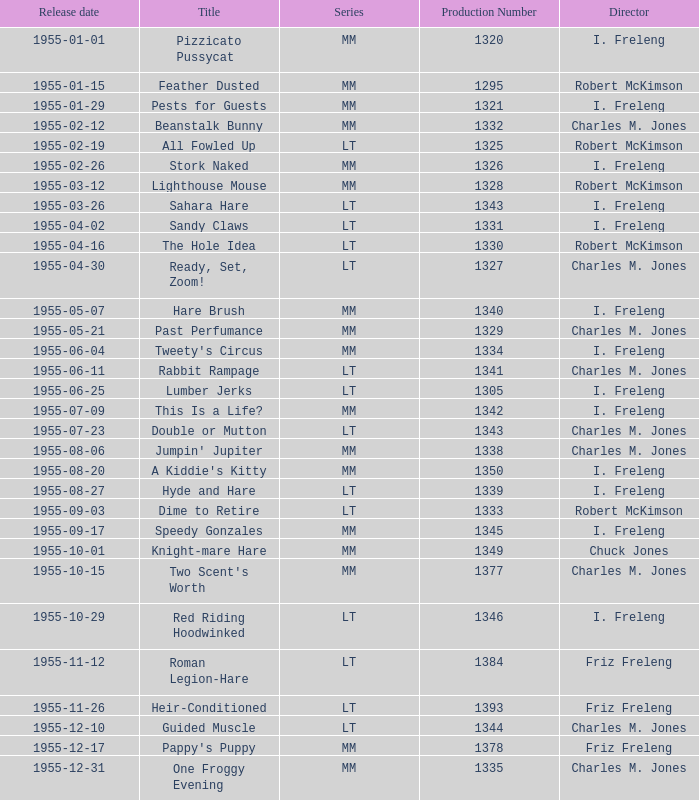Would you mind parsing the complete table? {'header': ['Release date', 'Title', 'Series', 'Production Number', 'Director'], 'rows': [['1955-01-01', 'Pizzicato Pussycat', 'MM', '1320', 'I. Freleng'], ['1955-01-15', 'Feather Dusted', 'MM', '1295', 'Robert McKimson'], ['1955-01-29', 'Pests for Guests', 'MM', '1321', 'I. Freleng'], ['1955-02-12', 'Beanstalk Bunny', 'MM', '1332', 'Charles M. Jones'], ['1955-02-19', 'All Fowled Up', 'LT', '1325', 'Robert McKimson'], ['1955-02-26', 'Stork Naked', 'MM', '1326', 'I. Freleng'], ['1955-03-12', 'Lighthouse Mouse', 'MM', '1328', 'Robert McKimson'], ['1955-03-26', 'Sahara Hare', 'LT', '1343', 'I. Freleng'], ['1955-04-02', 'Sandy Claws', 'LT', '1331', 'I. Freleng'], ['1955-04-16', 'The Hole Idea', 'LT', '1330', 'Robert McKimson'], ['1955-04-30', 'Ready, Set, Zoom!', 'LT', '1327', 'Charles M. Jones'], ['1955-05-07', 'Hare Brush', 'MM', '1340', 'I. Freleng'], ['1955-05-21', 'Past Perfumance', 'MM', '1329', 'Charles M. Jones'], ['1955-06-04', "Tweety's Circus", 'MM', '1334', 'I. Freleng'], ['1955-06-11', 'Rabbit Rampage', 'LT', '1341', 'Charles M. Jones'], ['1955-06-25', 'Lumber Jerks', 'LT', '1305', 'I. Freleng'], ['1955-07-09', 'This Is a Life?', 'MM', '1342', 'I. Freleng'], ['1955-07-23', 'Double or Mutton', 'LT', '1343', 'Charles M. Jones'], ['1955-08-06', "Jumpin' Jupiter", 'MM', '1338', 'Charles M. Jones'], ['1955-08-20', "A Kiddie's Kitty", 'MM', '1350', 'I. Freleng'], ['1955-08-27', 'Hyde and Hare', 'LT', '1339', 'I. Freleng'], ['1955-09-03', 'Dime to Retire', 'LT', '1333', 'Robert McKimson'], ['1955-09-17', 'Speedy Gonzales', 'MM', '1345', 'I. Freleng'], ['1955-10-01', 'Knight-mare Hare', 'MM', '1349', 'Chuck Jones'], ['1955-10-15', "Two Scent's Worth", 'MM', '1377', 'Charles M. Jones'], ['1955-10-29', 'Red Riding Hoodwinked', 'LT', '1346', 'I. Freleng'], ['1955-11-12', 'Roman Legion-Hare', 'LT', '1384', 'Friz Freleng'], ['1955-11-26', 'Heir-Conditioned', 'LT', '1393', 'Friz Freleng'], ['1955-12-10', 'Guided Muscle', 'LT', '1344', 'Charles M. Jones'], ['1955-12-17', "Pappy's Puppy", 'MM', '1378', 'Friz Freleng'], ['1955-12-31', 'One Froggy Evening', 'MM', '1335', 'Charles M. Jones']]} What is the highest production number released on 1955-04-02 with i. freleng as the director? 1331.0. 